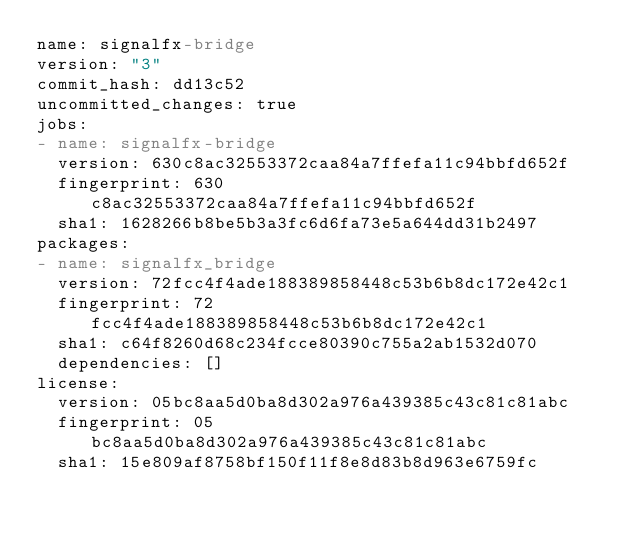Convert code to text. <code><loc_0><loc_0><loc_500><loc_500><_YAML_>name: signalfx-bridge
version: "3"
commit_hash: dd13c52
uncommitted_changes: true
jobs:
- name: signalfx-bridge
  version: 630c8ac32553372caa84a7ffefa11c94bbfd652f
  fingerprint: 630c8ac32553372caa84a7ffefa11c94bbfd652f
  sha1: 1628266b8be5b3a3fc6d6fa73e5a644dd31b2497
packages:
- name: signalfx_bridge
  version: 72fcc4f4ade188389858448c53b6b8dc172e42c1
  fingerprint: 72fcc4f4ade188389858448c53b6b8dc172e42c1
  sha1: c64f8260d68c234fcce80390c755a2ab1532d070
  dependencies: []
license:
  version: 05bc8aa5d0ba8d302a976a439385c43c81c81abc
  fingerprint: 05bc8aa5d0ba8d302a976a439385c43c81c81abc
  sha1: 15e809af8758bf150f11f8e8d83b8d963e6759fc
</code> 